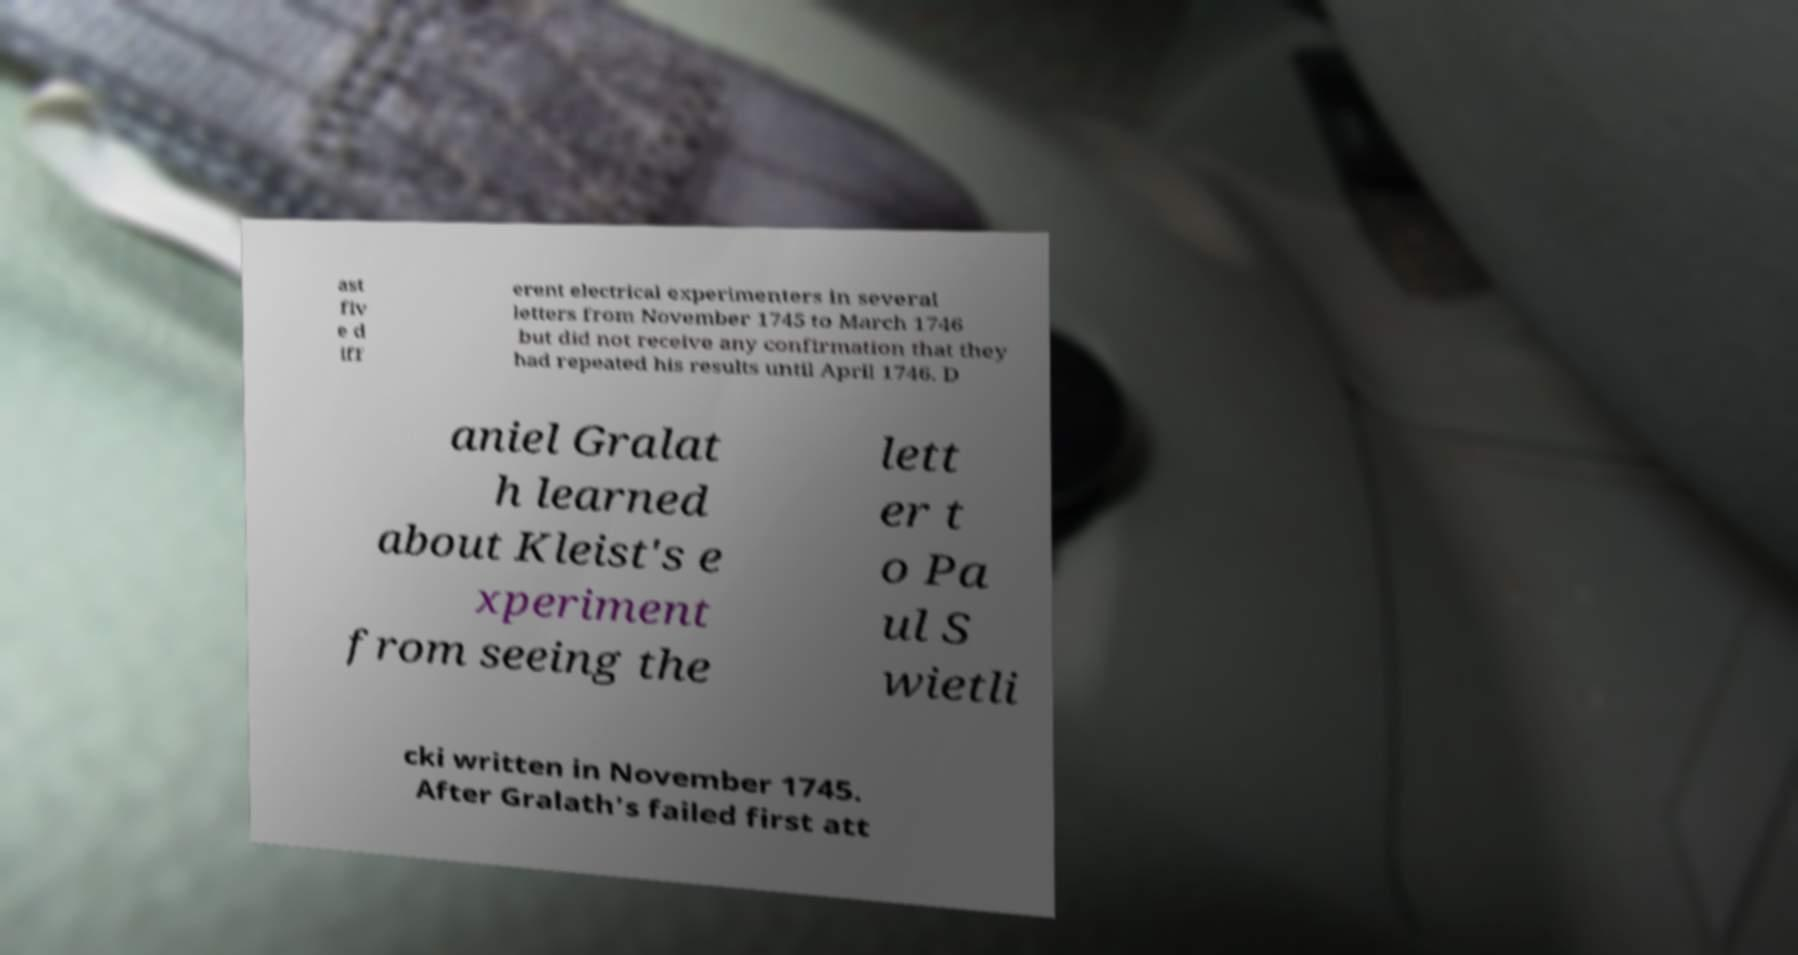Can you accurately transcribe the text from the provided image for me? ast fiv e d iff erent electrical experimenters in several letters from November 1745 to March 1746 but did not receive any confirmation that they had repeated his results until April 1746. D aniel Gralat h learned about Kleist's e xperiment from seeing the lett er t o Pa ul S wietli cki written in November 1745. After Gralath's failed first att 